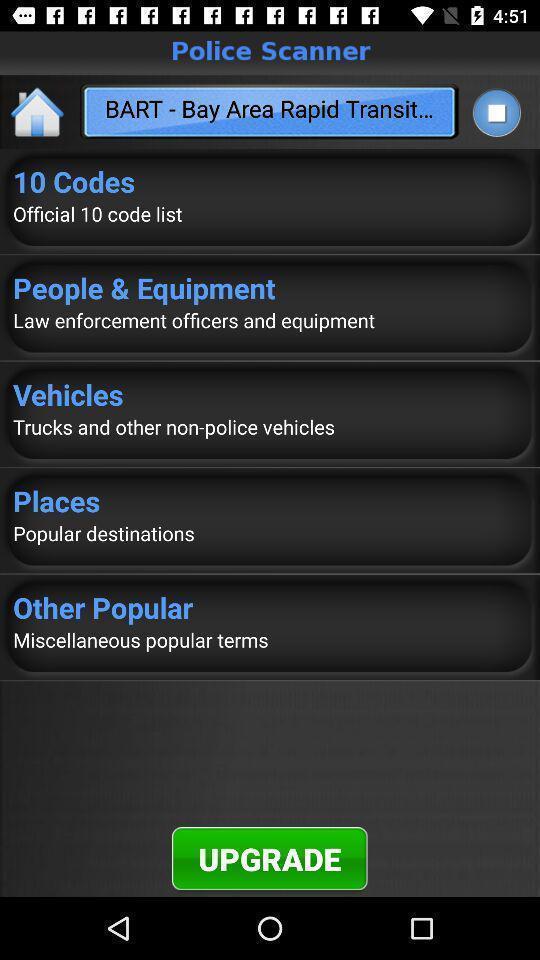Describe the content in this image. Page displays to upgrade an app. 